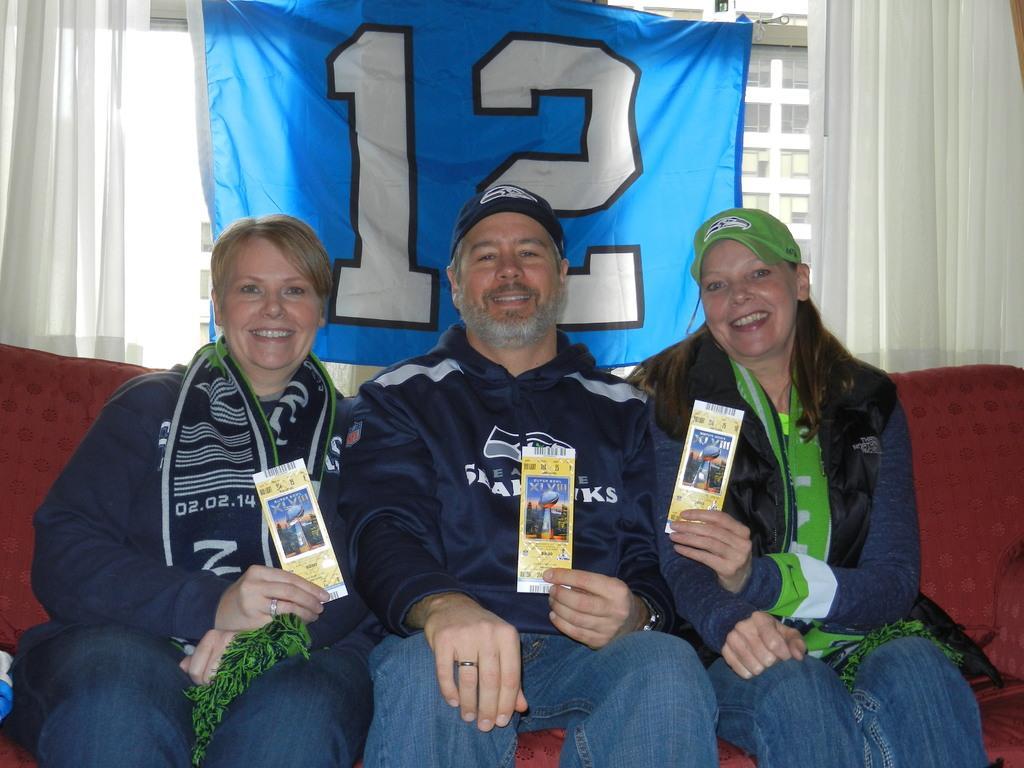Can you describe this image briefly? In this image I can see a men and two women are sitting on a red colour sofa. I can see they all are wearing jackets, jeans and two of them are wearing caps. I can also see smile on their faces and here I can see they all are holding yellow colour things. In the background can see white colour curtains, blue colour cloth and on it I can see few numbers are written. 